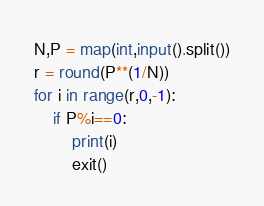<code> <loc_0><loc_0><loc_500><loc_500><_Python_>N,P = map(int,input().split())
r = round(P**(1/N))
for i in range(r,0,-1):
    if P%i==0:
        print(i)
        exit()</code> 